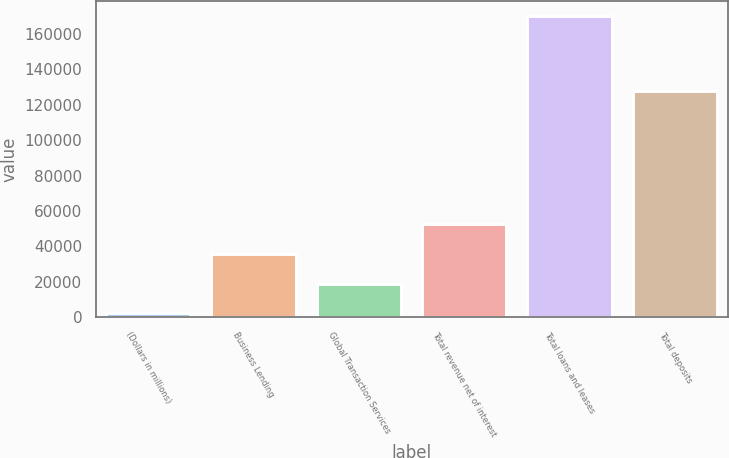Convert chart. <chart><loc_0><loc_0><loc_500><loc_500><bar_chart><fcel>(Dollars in millions)<fcel>Business Lending<fcel>Global Transaction Services<fcel>Total revenue net of interest<fcel>Total loans and leases<fcel>Total deposits<nl><fcel>2017<fcel>35633.8<fcel>18825.4<fcel>52442.2<fcel>170101<fcel>127720<nl></chart> 